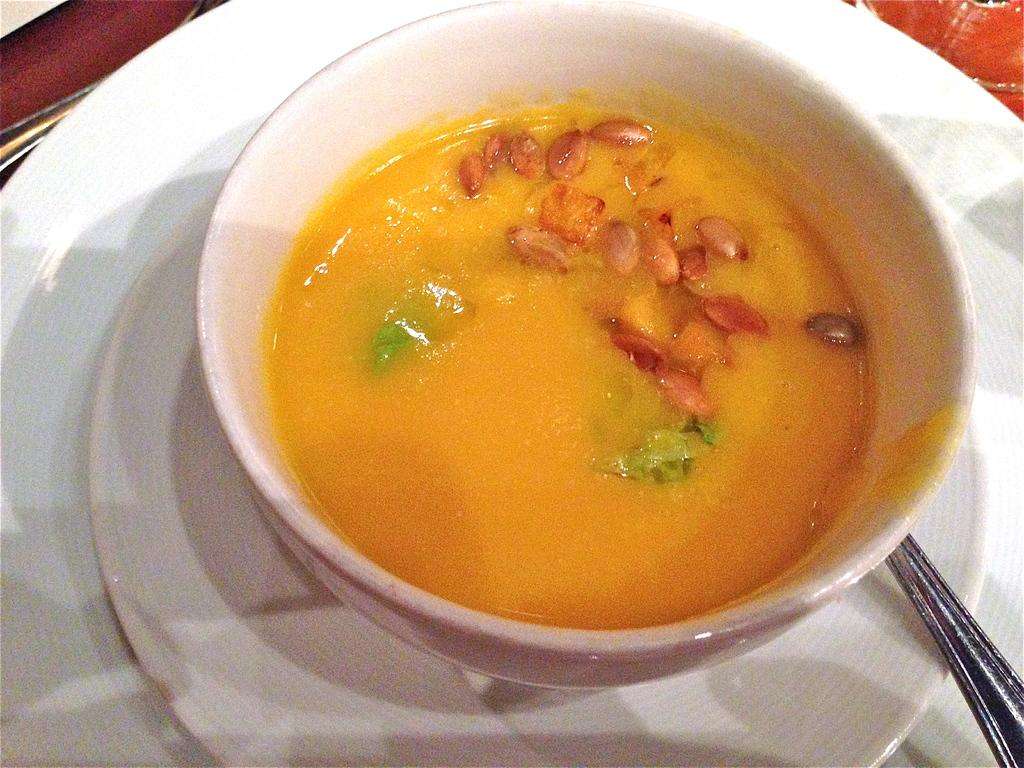What is the main object in the center of the image? There is a bowl in the center of the image. What is inside the bowl? The bowl contains food items. What is located around the bowl? There is a plate surrounding the bowl. Where can a utensil be found in the image? There is a spoon in the bottom right side of the image. What type of flower is growing in the bowl? There is no flower present in the image; the bowl contains food items. 